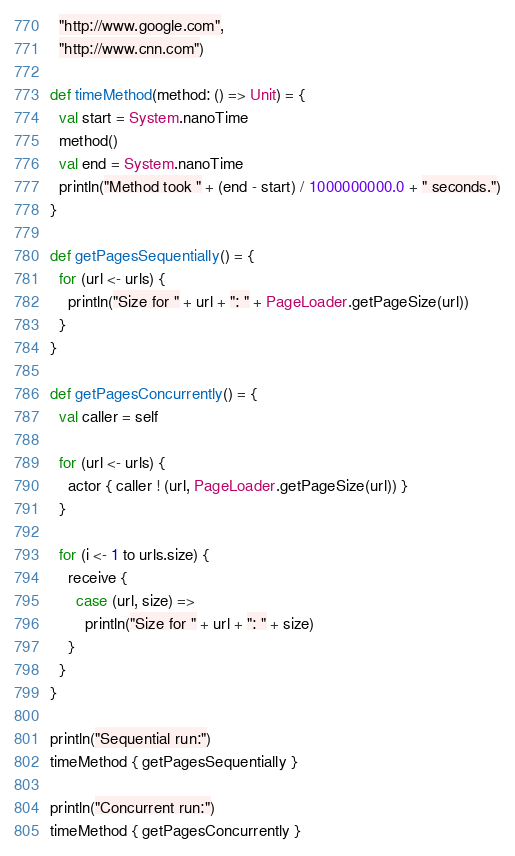<code> <loc_0><loc_0><loc_500><loc_500><_Scala_>  "http://www.google.com",
  "http://www.cnn.com")

def timeMethod(method: () => Unit) = {
  val start = System.nanoTime
  method()
  val end = System.nanoTime
  println("Method took " + (end - start) / 1000000000.0 + " seconds.")
}

def getPagesSequentially() = {
  for (url <- urls) {
    println("Size for " + url + ": " + PageLoader.getPageSize(url))
  }
}

def getPagesConcurrently() = {
  val caller = self

  for (url <- urls) {
    actor { caller ! (url, PageLoader.getPageSize(url)) }
  }

  for (i <- 1 to urls.size) {
    receive {
      case (url, size) =>
        println("Size for " + url + ": " + size)
    }
  }
}

println("Sequential run:")
timeMethod { getPagesSequentially }

println("Concurrent run:")
timeMethod { getPagesConcurrently }
</code> 